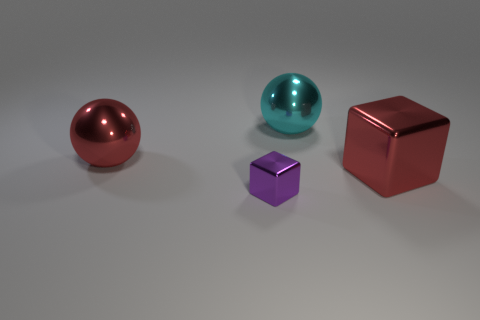Subtract 1 cubes. How many cubes are left? 1 Subtract all red cubes. How many cyan balls are left? 1 Add 2 small brown shiny blocks. How many objects exist? 6 Subtract all red balls. How many balls are left? 1 Subtract 0 gray cylinders. How many objects are left? 4 Subtract all cyan balls. Subtract all purple cylinders. How many balls are left? 1 Subtract all big cyan matte things. Subtract all large metal blocks. How many objects are left? 3 Add 1 cyan metallic things. How many cyan metallic things are left? 2 Add 3 purple blocks. How many purple blocks exist? 4 